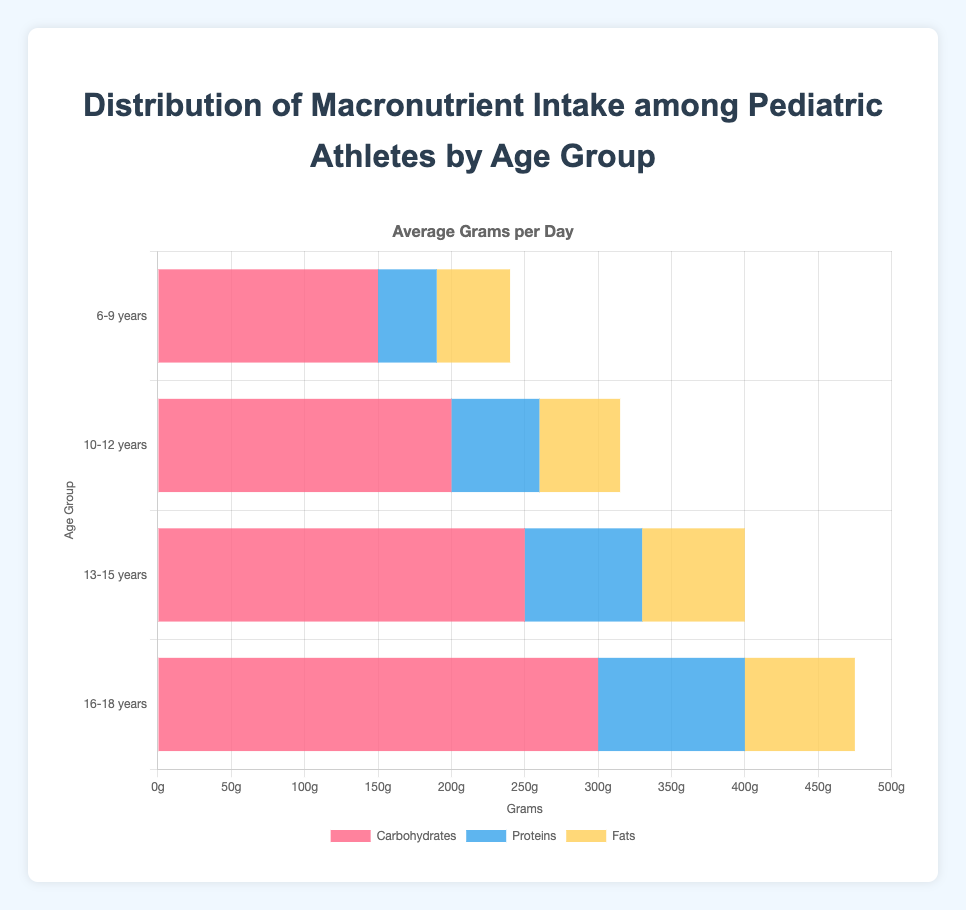Which age group has the highest average intake of carbohydrates? To find this, look at the lengths of the bar representing carbohydrates for each age group. The age group 16-18 years has the longest bar for carbohydrates, indicating the highest average intake.
Answer: 16-18 years What is the difference in average grams of protein intake per day between the 6-9 years and 16-18 years age groups? The average grams per day of protein intake for 6-9 years is 40 grams. For 16-18 years, it is 100 grams. The difference is calculated as 100 - 40 = 60 grams.
Answer: 60 grams Which macronutrient shows consistent intake percentages (around 20%) for age groups 10-12, 13-15, and 16-18 years? Observing the bars, the protein intake percentages for these age groups are 20%, indicating consistent intake.
Answer: Proteins How does the average fat intake in grams per day for the 13-15 years age group compare with the same for the 6-9 years age group? The bars for fats show 70 grams for the 13-15 years group and 50 grams for the 6-9 years group. The 13-15 years group has higher average fat intake by 70 - 50 = 20 grams.
Answer: 20 grams more Calculate the combined average daily intake in grams of carbohydrates and proteins for the 10-12 years age group. The average daily intake for carbohydrates is 200 grams, and for proteins, it is 60 grams for this age group. Summing these gives 200 + 60 = 260 grams.
Answer: 260 grams Do any age groups have equal average daily intake in grams for fats and proteins? Comparing the bars for fats and proteins, no single age group has equal average daily intake for either macronutrient.
Answer: No Which age group shows the least variation in average daily intake among the three macronutrients? Looking at the lengths of the bars for each macronutrient within each age group, the 10-12 years age group shows the least variation.
Answer: 10-12 years What is the percentage increase in average daily carbohydrate intake from the 6-9 years group to the 16-18 years group? The average carbohydrate intake for 6-9 years is 150 grams and for 16-18 years is 300 grams. The percentage increase is calculated as ((300 - 150) / 150) * 100 = 100%.
Answer: 100% Which age group has the second-highest average grams per day intake of fats? Observing the bars representing fats, the 10-12 years age group has the second-highest average intake at 55 grams.
Answer: 10-12 years 